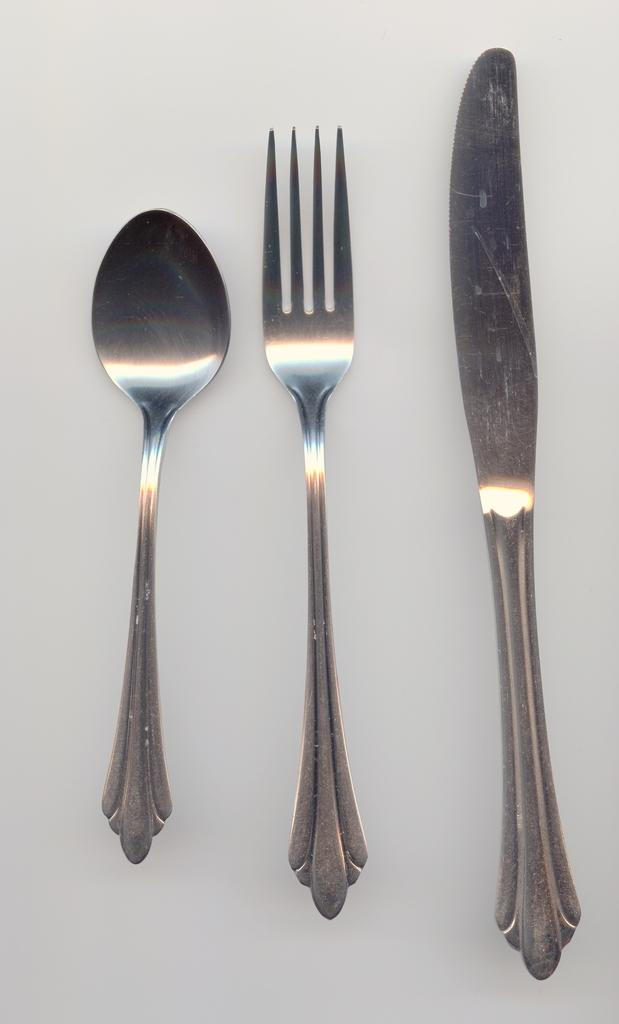What type of utensils can be seen in the image? There is a spoon, a fork, and a knife in the image. What is the color of the surface on which the utensils are placed? The objects are placed on a white surface. What type of paint is being used by the spoon in the image? There is no paint or painting activity present in the image; the spoon is simply a utensil. What arithmetic problem is the fork attempting to solve in the image? There is no arithmetic problem or any indication of a mathematical activity involving the fork in the image. 